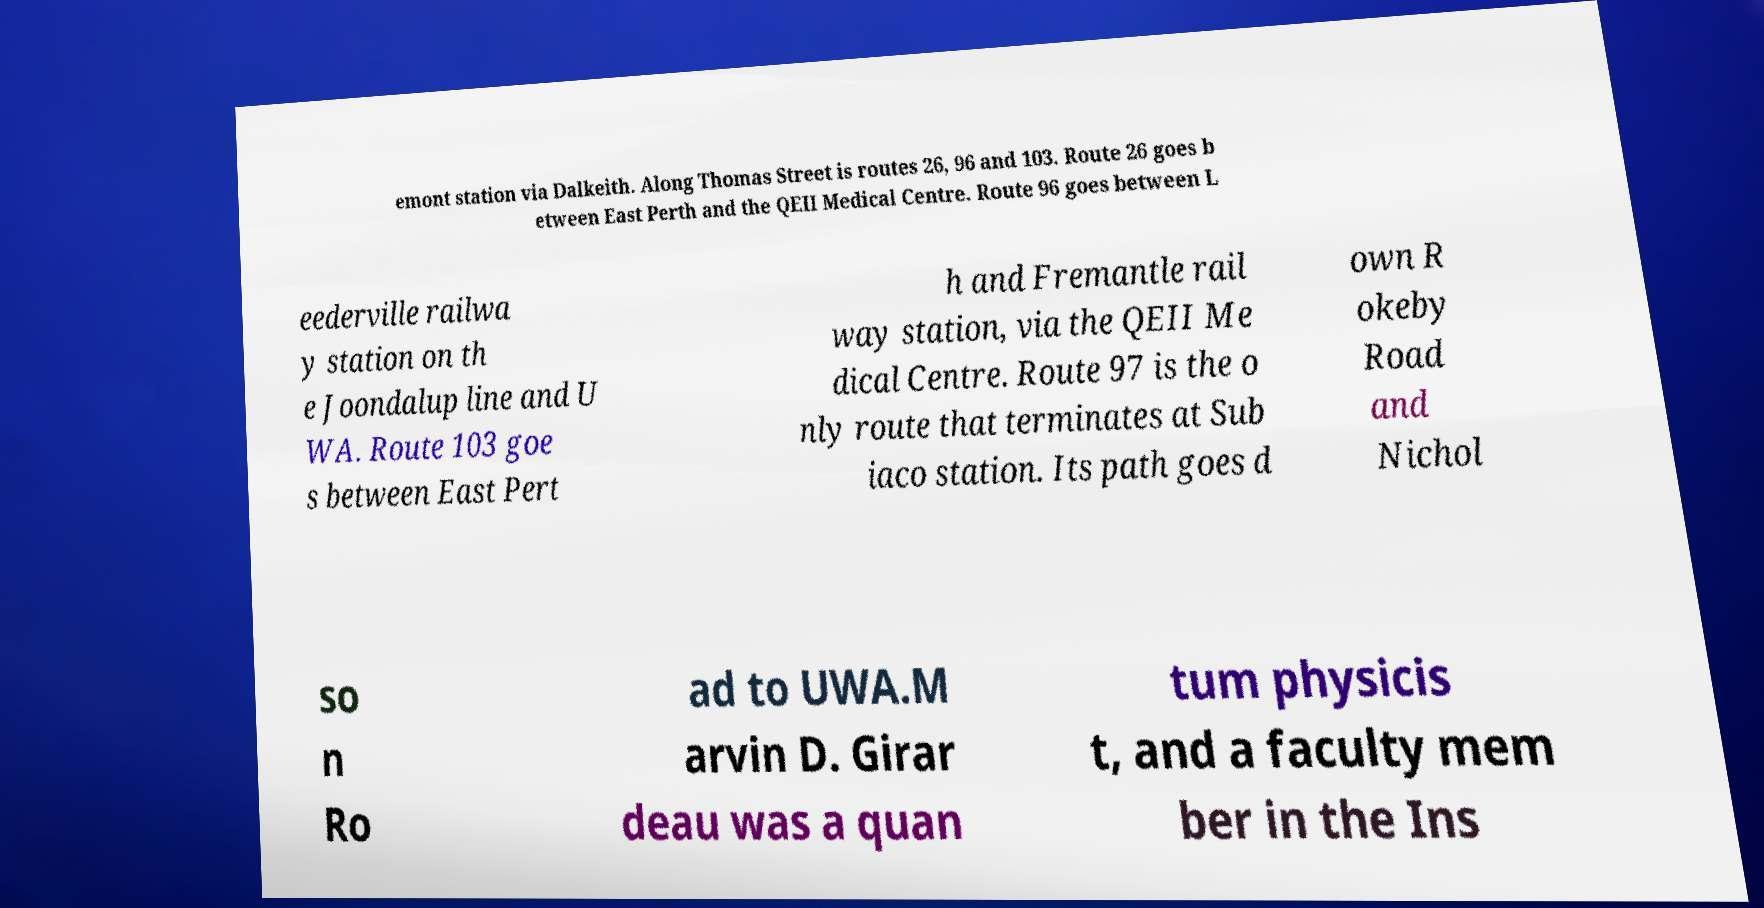What messages or text are displayed in this image? I need them in a readable, typed format. emont station via Dalkeith. Along Thomas Street is routes 26, 96 and 103. Route 26 goes b etween East Perth and the QEII Medical Centre. Route 96 goes between L eederville railwa y station on th e Joondalup line and U WA. Route 103 goe s between East Pert h and Fremantle rail way station, via the QEII Me dical Centre. Route 97 is the o nly route that terminates at Sub iaco station. Its path goes d own R okeby Road and Nichol so n Ro ad to UWA.M arvin D. Girar deau was a quan tum physicis t, and a faculty mem ber in the Ins 